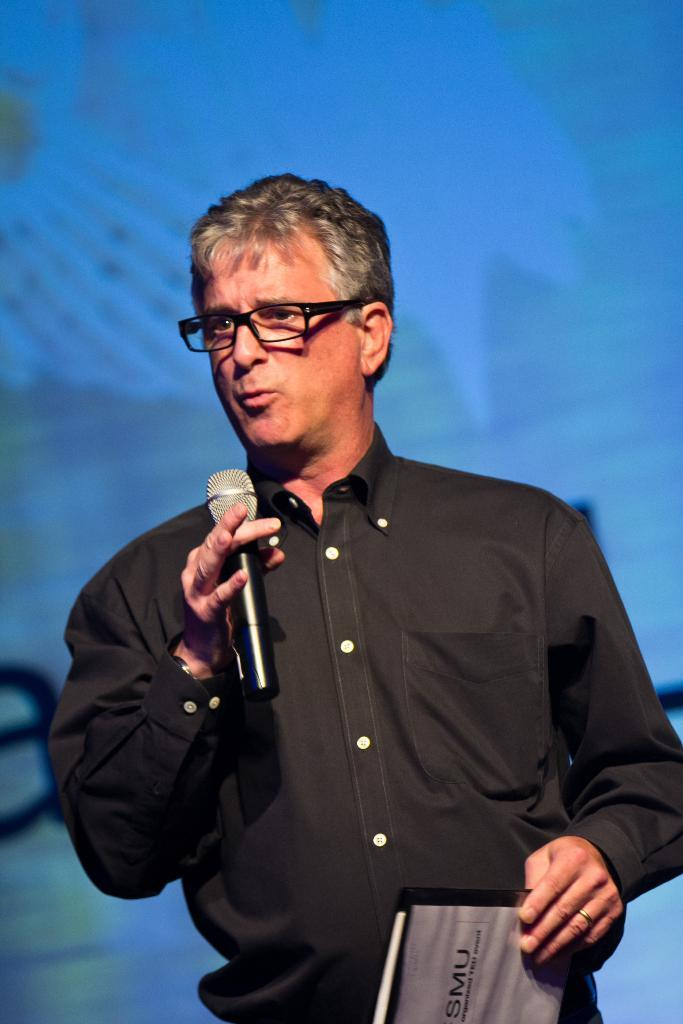What is the person in the image holding? The person is holding a mic and a book. What can be seen on the person's face? The person is wearing spectacles. What is present in the background of the image? There is a screen in the background of the image. What is the weight of the love in the image? There is no mention of love or weight in the image, so it cannot be determined. 